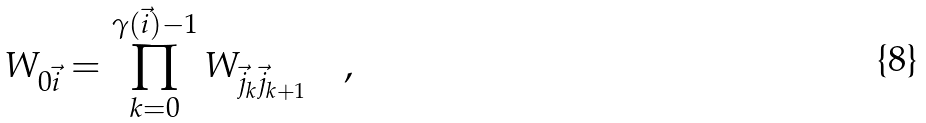<formula> <loc_0><loc_0><loc_500><loc_500>W _ { 0 \vec { i } } = \prod _ { k = 0 } ^ { \gamma ( { \vec { i } } ) - 1 } W _ { \vec { j } _ { k } \vec { j } _ { k + 1 } } \quad ,</formula> 